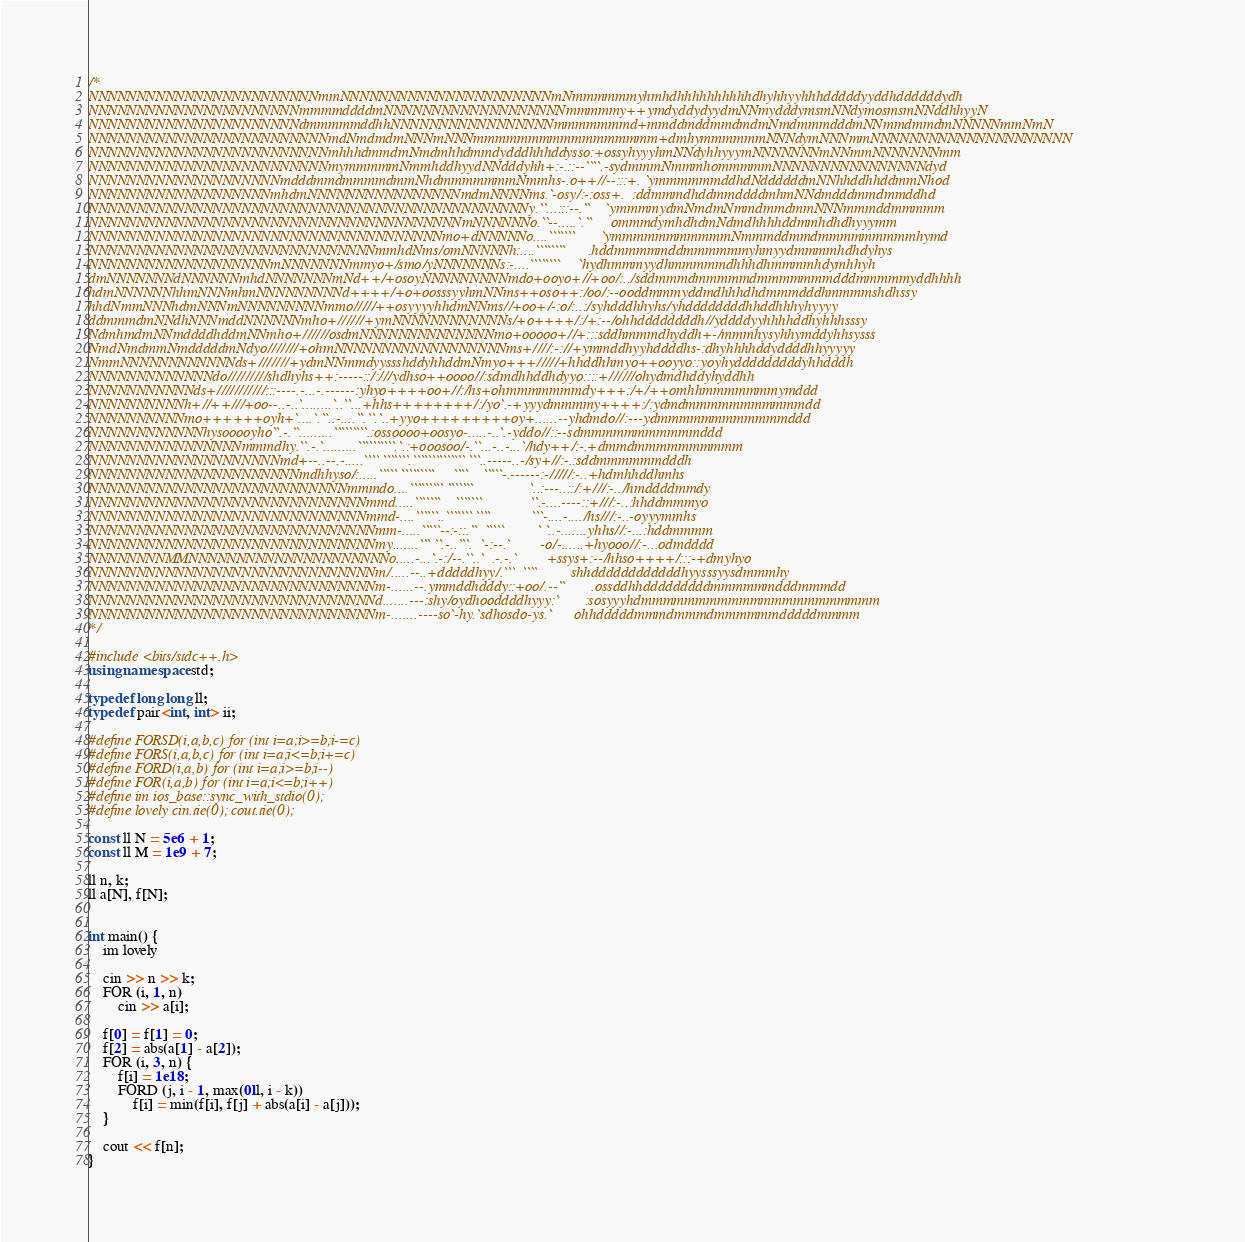<code> <loc_0><loc_0><loc_500><loc_500><_C++_>/*
NNNNNNNNNNNNNNNNNNNNNNNNmmNNNNNNNNNNNNNNNNNNNNNNmNmmmmmmyhmhdhhhhhhhhhhdhyhhyyhhhdddddyyddhddddddydh
NNNNNNNNNNNNNNNNNNNNNNmmmmddddmNNNNNNNNNNNNNNNNNNNmmmmmy++ymdyddydyydmNNmydddymsmNNdymosmsmNNddhhyyN
NNNNNNNNNNNNNNNNNNNNNNdmmmmmddhhNNNNNNNNNNNNNNNNNmmmmmmmd+mmddmddmmdmdmNmdmmmdddmNNmmdmmdmNNNNNmmNmN
NNNNNNNNNNNNNNNNNNNNNNNNNmdNmdmdmNNNmNNNmmmmmmmmmmmmmmmmm+dmhymmmmmmNNNdymNNNmmNNNNNNNNNNNNNNNNNNNNN
NNNNNNNNNNNNNNNNNNNNNNNNNmhhhdmmdmNmdmhhdmmdydddhhhddysso:+ossyhyyyhmNNdyhhyyymNNNNNNNmNNmmNNNNNNNmm
NNNNNNNNNNNNNNNNNNNNNNNNNmymmmmmNmmhddhyydNNdddyhh+:-.::--````.-sydmmmNmmmhommmmmNNNNNNNNNNNNNNNNdyd
NNNNNNNNNNNNNNNNNNNNmdddmmdmmmmdmmNhdmmmmmmmNmmhs-.o++//--:::+. `ymmmmmmddhdNddddddmNNhhddhhddmmNhod
NNNNNNNNNNNNNNNNNNNmhdmNNNNNNNNNNNNNNNNmdmNNNNms.`-osy/:-:oss+.  :ddmmmdhddmmddddmhmNNdmdddmmdmmddhd
NNNNNNNNNNNNNNNNNNNNNNNNNNNNNNNNNNNNNNNNNNNNNNy.``...:::--.``    `ymmmmydmNmdmNmmdmmdmmNNNmmmddmmmmm
NNNNNNNNNNNNNNNNNNNNNNNNNNNNNNNNNNNNNNNmNNNNNNo.``--.....`.``     ommmdymhdhdmNdmdhhhhddmmhdhdhyyymm
NNNNNNNNNNNNNNNNNNNNNNNNNNNNNNNNNNNNNmo+dNNNNNo....```````       `ymmmmmmmmmmmNmmmddmmdmmmmmmmmmhymd
NNNNNNNNNNNNNNNNNNNNNNNNNNNNNNmmhdNms/omNNNNNh:....````````      .hddmmmmmddmmmmmmyhmyydmmmmhdhdyhys
NNNNNNNNNNNNNNNNNNNmNNNNNNNmmyo+/smo/yNNNNNNNs:-....````````     `hydhmmmyydhmmmmmdhhhdhmmmmhdymhhyh
dmNNNNNNNdNNNNNNmhdNNNNNNNmNd++/+osoyNNNNNNNNNmdo+ooyo+//+oo/:../sddmmmdmmmmmdmmmmmmmdddmmmmmyddhhhh
hdmNNNNNNhhmNNNmhmNNNNNNNNNd++++/+o+oosssyyhmNNms++oso++:/oo/:--ooddmmmyddmdhhhdhdmmmdddhmmmmshdhssy
hhdNmmNNNhdmNNNmNNNNNNNNNmmo/////++osyyyyhhdmNNms//+oo+/-:o/:..:/syhdddhhyhs/yhddddddddhhddhhhyhyyyy
ddmmmdmNNdhNNNmddNNNNNNmho+//////+ymNNNNNNNNNNNNs/+o++++/:/+:--/ohhddddddddh//yddddyyhhhhddhyhhhsssy
NdmhmdmNNmddddhddmNNmho+//////osdmNNNNNNNNNNNNNNmo+ooooo+//+:::sddhmmmdhyddh+-/mmmhysyhhymddyhhsysss
NmdNmdmmNmdddddmNdyo///////+ohmNNNNNNNNNNNNNNNNNNms+////:-://+ymmddhyyhddddhs-:dhyhhhhddyddddhhyyyyy
NmmNNNNNNNNNNNNds+///////+ydmNNmmdyyssshddyhhddmNmyo+++/////+hhddhhmyo++ooyyo::yoyhydddddddddyhhdddh
NNNNNNNNNNNNNdo/////////shdhyhs++:-----::/:///ydhso++oooo//:sdmdhhddhdyyo::::+//////ohydmdhddyhyddhh
NNNNNNNNNNNds+///////////:::----.-...-.------:yhyo++++oo+//:/hs+ohmmmmmmmdy+++:/+/++omhhmmmmmmmymddd
NNNNNNNNNNh+//++///+oo--..-..`........`..``...+hhs++++++++/:/yo`.-+yyydmmmmy++++:/:ydmdmmmmmmmmmmmdd
NNNNNNNNNNmo++++++oyh+`....`.``..-....``.``.`..+yyo+++++++++oy+......--yhdmdo//:---ydmmmmmmmmmmmmddd
NNNNNNNNNNNNhysooooyho``.-.``.........`````````.:ossoooo+oosyo-.....-..`.-yddo//::--sdmmmmmmmmmmmddd
NNNNNNNNNNNNNNNNmmmdhy.``.-.`.........``````````.`.:+ooosoo/-.``...-..-...`/hdy++/:-.+dmmdmmmmmmmmmm
NNNNNNNNNNNNNNNNNNNNmd+--..--.-.....```` ```````.`````````````` ```..-----..-/sy+//:-.:sddmmmmmmdddh
NNNNNNNNNNNNNNNNNNNNNNmdhhyso/:.....````` `````````     ````    `````-.------:-/////:-..+hdmhhddhmhs
NNNNNNNNNNNNNNNNNNNNNNNNNNNmmmdo....````````` ```````               `..:---..::/:+///:-../hmddddmmdy
NNNNNNNNNNNNNNNNNNNNNNNNNNNNNmmd.....```````    ```````             ``.-....----::+///:-..:hhddmmmyo
NNNNNNNNNNNNNNNNNNNNNNNNNNNNNmmd-....``````..``````` ````           ```-....-..../hs///:-..-oyyymmhs
NNNNNNNNNNNNNNNNNNNNNNNNNNNNNNmm-.....`````--:-::.``  `````         ` `..-.......yhhs//:-...:hddmmmm
NNNNNNNNNNNNNNNNNNNNNNNNNNNNNNmy.......``` ``.-..```.  `-:--.`        -o/-......+hyooo//:-...odmdddd
NNNNNNNNMMNNNNNNNNNNNNNNNNNNNNNo.....-...`.-:/--.``..`  .-.-.`        +ssys+:--/hhso++++/:::-+dmyhyo
NNNNNNNNNNNNNNNNNNNNNNNNNNNNNNm/.....--..+dddddhyy/.```  ````         shhddddddddddddhyysssyysdmmmhy
NNNNNNNNNNNNNNNNNNNNNNNNNNNNNNm-......--.ymmddhdddy::+oo/.--``       .ossddhhdddddddddmmmmmmdddmmmdd
NNNNNNNNNNNNNNNNNNNNNNNNNNNNNNd.......---:shy/oydhooddddhyyy:`       :sosyyyhdmmmmmmmmmmmmmmmmmmmmmm
NNNNNNNNNNNNNNNNNNNNNNNNNNNNNNm-.......----so`-hy.`sdhosdo-ys.`      ohhdddddmmmdmmmdmmmmmmdddddmmmm
*/

#include <bits/stdc++.h>
using namespace std;

typedef long long ll;
typedef pair<int, int> ii;

#define FORSD(i,a,b,c) for (int i=a;i>=b;i-=c)
#define FORS(i,a,b,c) for (int i=a;i<=b;i+=c)
#define FORD(i,a,b) for (int i=a;i>=b;i--)
#define FOR(i,a,b) for (int i=a;i<=b;i++)
#define im ios_base::sync_with_stdio(0);
#define lovely cin.tie(0); cout.tie(0);

const ll N = 5e6 + 1;
const ll M = 1e9 + 7;

ll n, k;
ll a[N], f[N];


int main() {
    im lovely

    cin >> n >> k;
    FOR (i, 1, n) 
        cin >> a[i];

    f[0] = f[1] = 0;
    f[2] = abs(a[1] - a[2]);
    FOR (i, 3, n) {
        f[i] = 1e18;
        FORD (j, i - 1, max(0ll, i - k)) 
            f[i] = min(f[i], f[j] + abs(a[i] - a[j]));
    }

    cout << f[n];
}</code> 